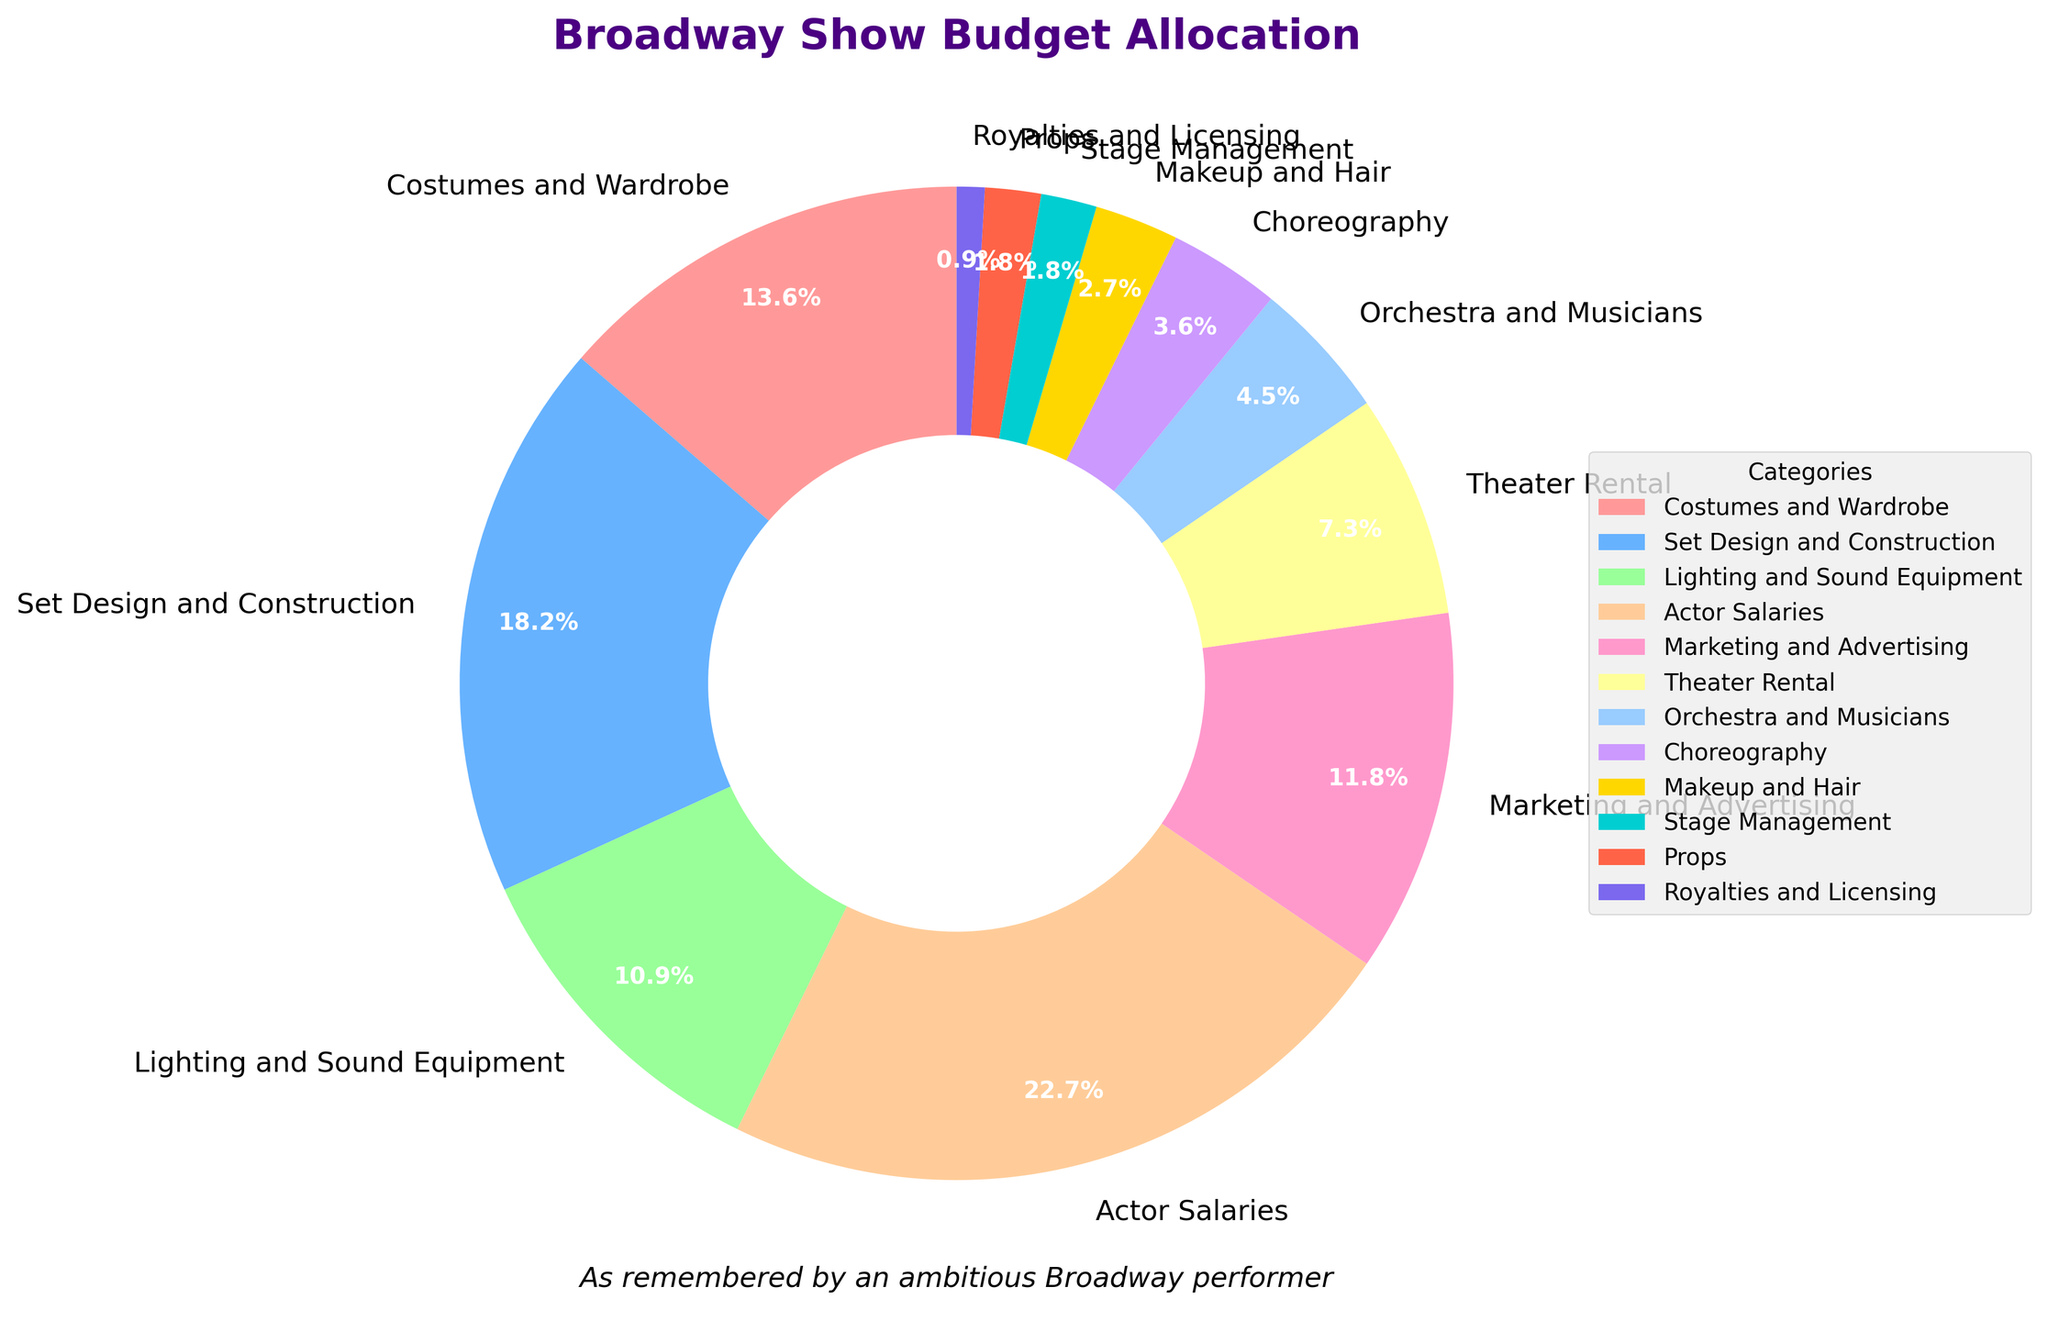What's the largest single expenditure in a typical Broadway show's budget? The largest single expenditure can be identified by looking at the largest percentage in the pie chart. In this case, the Actor Salaries category, with 25%, is the biggest expenditure.
Answer: Actor Salaries What is the total percentage allocated to elements related to performers (Actor Salaries, Orchestra and Musicians, Choreography, and Makeup and Hair)? To find the total percentage, sum the percentages of all categories related to performers: Actor Salaries (25%) + Orchestra and Musicians (5%) + Choreography (4%) + Makeup and Hair (3%). This equals 25 + 5 + 4 + 3 = 37%.
Answer: 37% How does the budget for Set Design and Construction compare to the budget for Lighting and Sound Equipment? Compare the percentages for Set Design and Construction (20%) and Lighting and Sound Equipment (12%). Set Design and Construction allocation is 20% - 12% = 8% higher than Lighting and Sound Equipment.
Answer: Set Design and Construction is 8% higher Which category occupies the smallest part of the budget? The smallest part of the budget is given to the category with the smallest percentage. In this case, Royalties and Licensing takes up 1% of the budget.
Answer: Royalties and Licensing What is the combined percentage for elements related to tech (Lighting and Sound Equipment, Stage Management, and Props)? To find the combined percentage, sum the individual percentages for these categories: Lighting and Sound Equipment (12%) + Stage Management (2%) + Props (2%). This equals 12 + 2 + 2 = 16%.
Answer: 16% Which spends more, Costumes and Wardrobe or Marketing and Advertising, and by how much? Compare the percentages of Costumes and Wardrobe (15%) and Marketing and Advertising (13%). Costumes and Wardrobe spends 15% - 13% = 2% more than Marketing and Advertising.
Answer: Costumes and Wardrobe by 2% How does the sum of the Theater Rental and Royalties and Licensing compare to Orchestra and Musicians? Sum the percentages for Theater Rental (8%) and Royalties and Licensing (1%), then compare this to Orchestra and Musicians (5%). Theater Rental and Royalties and Licensing together is 8% + 1% = 9%, which is 9% - 5% = 4% more than Orchestra and Musicians.
Answer: Theater Rental and Royalties and Licensing is 4% more By how much does the budget for Set Design and Construction exceed the budget for Marketing and Advertising? Compare the percentages for Set Design and Construction (20%) and Marketing and Advertising (13%). The excess is calculated as 20% - 13% = 7%.
Answer: 7% What percentage of the budget is allocated towards elements other than Actor Salaries? To find this, subtract the percentage for Actor Salaries (25%) from 100%: 100% - 25% = 75%.
Answer: 75% What is the percentage difference between the budget for Costumes and Wardrobe and the budget for Choreography? Subtract the percentage for Choreography (4%) from the percentage for Costumes and Wardrobe (15%): 15% - 4% = 11%.
Answer: 11% 